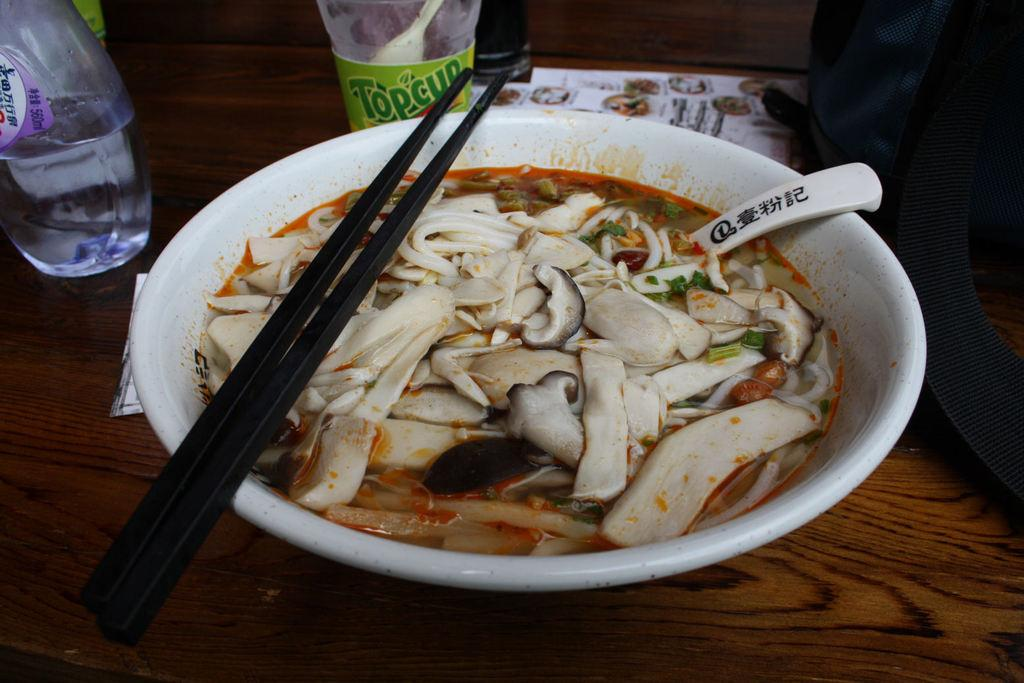What is in the bowl that is visible in the image? There is food in a bowl in the image. What utensils are visible in the image? Chopsticks and a spoon are visible in the image. What type of paper is present in the image? There are papers in the image. What type of containers are visible in the image? Bottles are visible in the image. What type of bag is present in the image? A bag is present in the image. What is the surface that the objects are placed on in the image? The objects are on a wooden platform. What type of industry is depicted in the image? There is no industry depicted in the image; it features food, utensils, papers, bottles, a bag, and a wooden platform. How many mice can be seen running around the food in the image? There are no mice present in the image. 